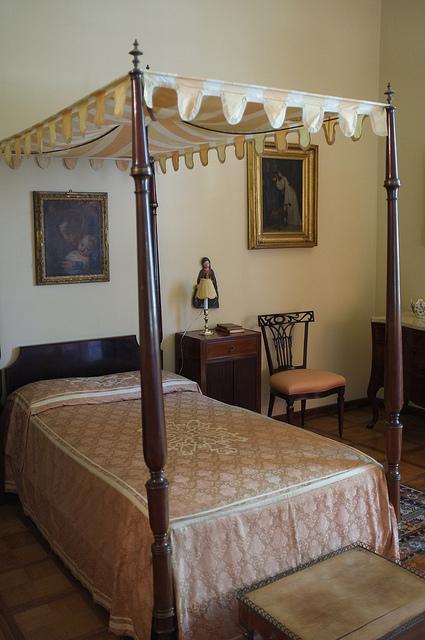How many paintings on the wall?
Give a very brief answer. 2. Is there a canopy on the bed?
Be succinct. Yes. What are at the end of the bed?
Be succinct. Chest. 